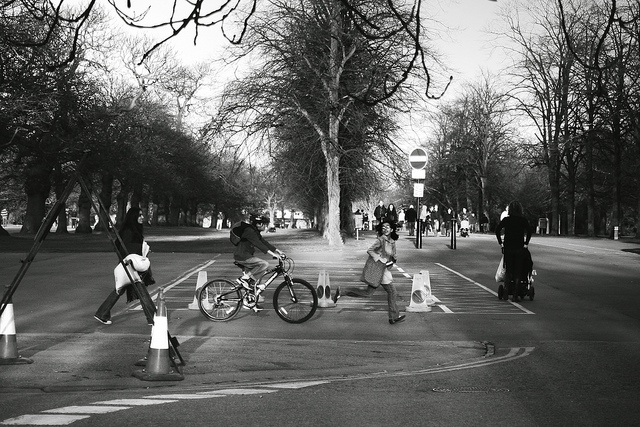Describe the objects in this image and their specific colors. I can see bicycle in gray, black, darkgray, and lightgray tones, people in gray, black, darkgray, and lightgray tones, people in gray, black, darkgray, and lightgray tones, people in gray, black, lightgray, and darkgray tones, and people in gray, black, darkgray, and lightgray tones in this image. 